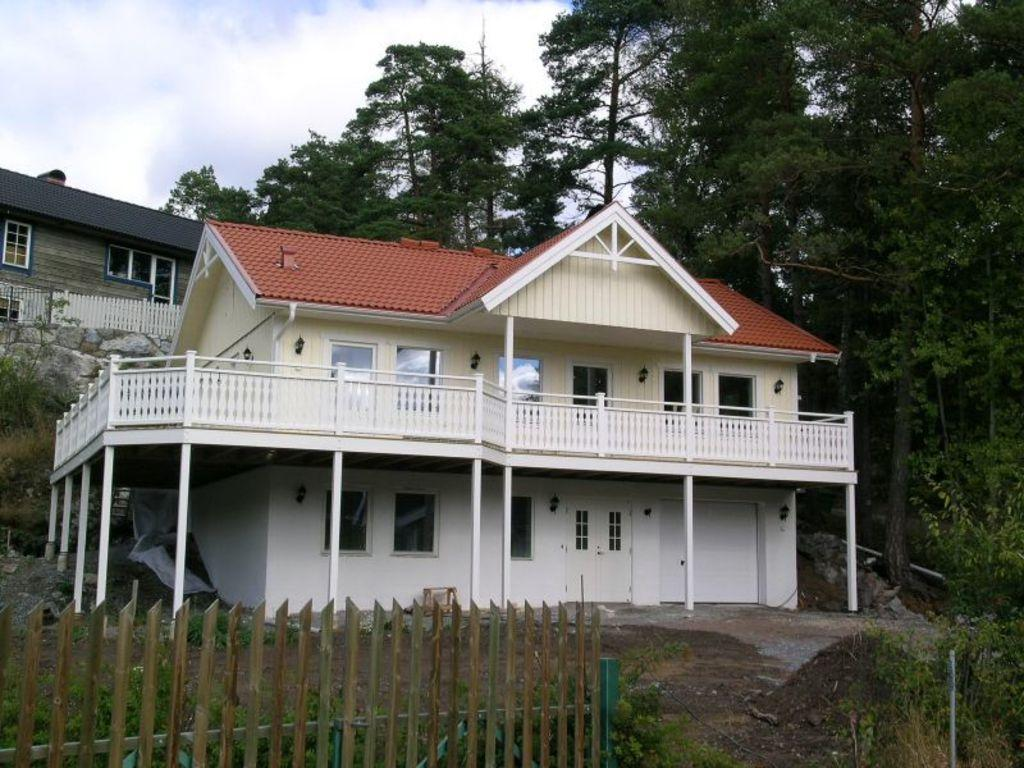What type of structures can be seen in the image? There are houses in the image. What other natural elements are present in the image? There are trees in the image. What can be seen in the sky in the image? There are clouds in the image. What is visible in the background of the image? The sky is visible in the image. What allows us to see inside the houses in the image? There are windows in the image. What type of flesh can be seen hanging from the trees in the image? There is no flesh present in the image; it features houses, trees, clouds, and the sky. 